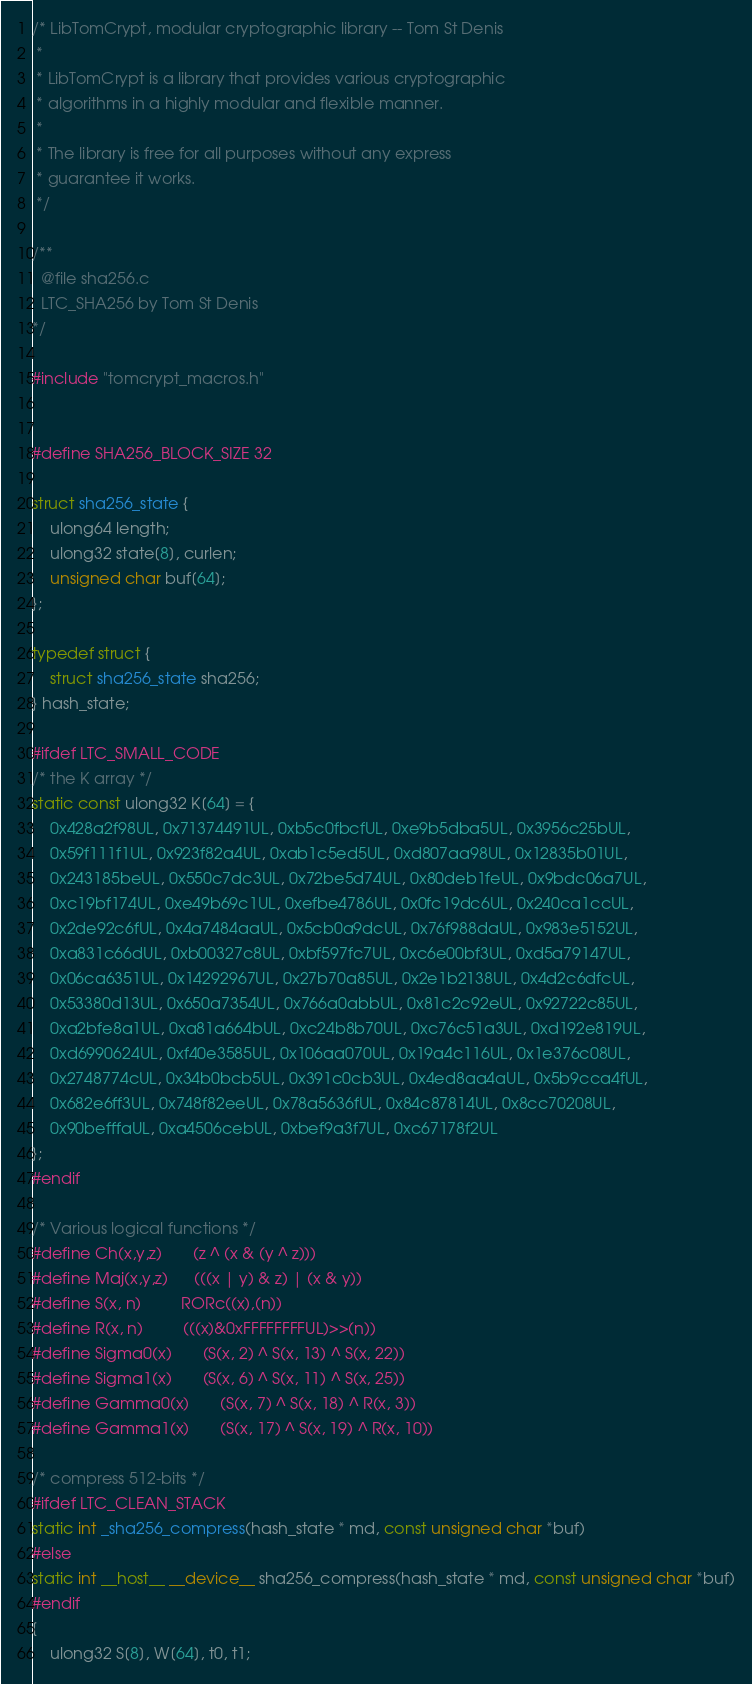<code> <loc_0><loc_0><loc_500><loc_500><_Cuda_>/* LibTomCrypt, modular cryptographic library -- Tom St Denis
 *
 * LibTomCrypt is a library that provides various cryptographic
 * algorithms in a highly modular and flexible manner.
 *
 * The library is free for all purposes without any express
 * guarantee it works.
 */

/**
  @file sha256.c
  LTC_SHA256 by Tom St Denis
*/

#include "tomcrypt_macros.h"


#define SHA256_BLOCK_SIZE 32

struct sha256_state {
    ulong64 length;
    ulong32 state[8], curlen;
    unsigned char buf[64];
};

typedef struct {
    struct sha256_state sha256;
} hash_state;

#ifdef LTC_SMALL_CODE
/* the K array */
static const ulong32 K[64] = {
    0x428a2f98UL, 0x71374491UL, 0xb5c0fbcfUL, 0xe9b5dba5UL, 0x3956c25bUL,
    0x59f111f1UL, 0x923f82a4UL, 0xab1c5ed5UL, 0xd807aa98UL, 0x12835b01UL,
    0x243185beUL, 0x550c7dc3UL, 0x72be5d74UL, 0x80deb1feUL, 0x9bdc06a7UL,
    0xc19bf174UL, 0xe49b69c1UL, 0xefbe4786UL, 0x0fc19dc6UL, 0x240ca1ccUL,
    0x2de92c6fUL, 0x4a7484aaUL, 0x5cb0a9dcUL, 0x76f988daUL, 0x983e5152UL,
    0xa831c66dUL, 0xb00327c8UL, 0xbf597fc7UL, 0xc6e00bf3UL, 0xd5a79147UL,
    0x06ca6351UL, 0x14292967UL, 0x27b70a85UL, 0x2e1b2138UL, 0x4d2c6dfcUL,
    0x53380d13UL, 0x650a7354UL, 0x766a0abbUL, 0x81c2c92eUL, 0x92722c85UL,
    0xa2bfe8a1UL, 0xa81a664bUL, 0xc24b8b70UL, 0xc76c51a3UL, 0xd192e819UL,
    0xd6990624UL, 0xf40e3585UL, 0x106aa070UL, 0x19a4c116UL, 0x1e376c08UL,
    0x2748774cUL, 0x34b0bcb5UL, 0x391c0cb3UL, 0x4ed8aa4aUL, 0x5b9cca4fUL,
    0x682e6ff3UL, 0x748f82eeUL, 0x78a5636fUL, 0x84c87814UL, 0x8cc70208UL,
    0x90befffaUL, 0xa4506cebUL, 0xbef9a3f7UL, 0xc67178f2UL
};
#endif

/* Various logical functions */
#define Ch(x,y,z)       (z ^ (x & (y ^ z)))
#define Maj(x,y,z)      (((x | y) & z) | (x & y))
#define S(x, n)         RORc((x),(n))
#define R(x, n)         (((x)&0xFFFFFFFFUL)>>(n))
#define Sigma0(x)       (S(x, 2) ^ S(x, 13) ^ S(x, 22))
#define Sigma1(x)       (S(x, 6) ^ S(x, 11) ^ S(x, 25))
#define Gamma0(x)       (S(x, 7) ^ S(x, 18) ^ R(x, 3))
#define Gamma1(x)       (S(x, 17) ^ S(x, 19) ^ R(x, 10))

/* compress 512-bits */
#ifdef LTC_CLEAN_STACK
static int _sha256_compress(hash_state * md, const unsigned char *buf)
#else
static int __host__ __device__ sha256_compress(hash_state * md, const unsigned char *buf)
#endif
{
    ulong32 S[8], W[64], t0, t1;</code> 